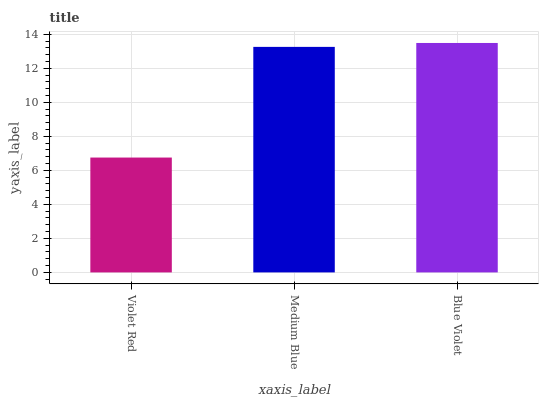Is Medium Blue the minimum?
Answer yes or no. No. Is Medium Blue the maximum?
Answer yes or no. No. Is Medium Blue greater than Violet Red?
Answer yes or no. Yes. Is Violet Red less than Medium Blue?
Answer yes or no. Yes. Is Violet Red greater than Medium Blue?
Answer yes or no. No. Is Medium Blue less than Violet Red?
Answer yes or no. No. Is Medium Blue the high median?
Answer yes or no. Yes. Is Medium Blue the low median?
Answer yes or no. Yes. Is Blue Violet the high median?
Answer yes or no. No. Is Blue Violet the low median?
Answer yes or no. No. 